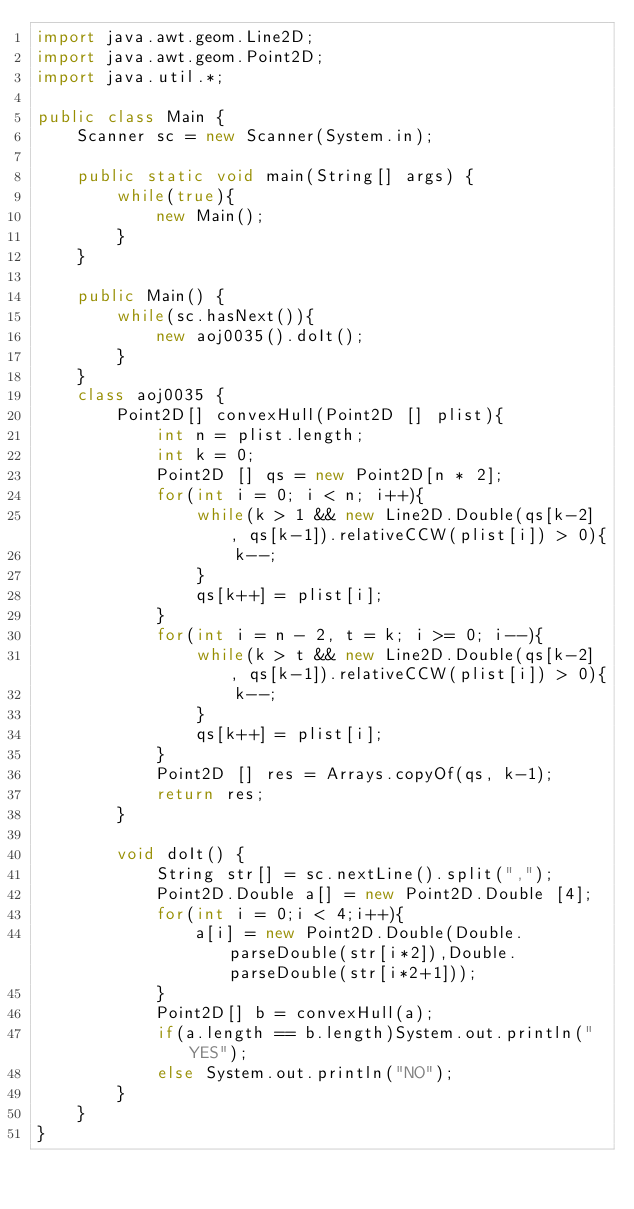<code> <loc_0><loc_0><loc_500><loc_500><_Java_>import java.awt.geom.Line2D;
import java.awt.geom.Point2D;
import java.util.*;

public class Main {
	Scanner sc = new Scanner(System.in);

	public static void main(String[] args) {
		while(true){
			new Main();	
		}
	}

	public Main() {
		while(sc.hasNext()){
			new aoj0035().doIt();
		}
	}
	class aoj0035 {
		Point2D[] convexHull(Point2D [] plist){
			int n = plist.length;
			int k = 0;
			Point2D [] qs = new Point2D[n * 2];
			for(int i = 0; i < n; i++){
				while(k > 1 && new Line2D.Double(qs[k-2] , qs[k-1]).relativeCCW(plist[i]) > 0){
					k--;
				}
				qs[k++] = plist[i];
			}
			for(int i = n - 2, t = k; i >= 0; i--){
				while(k > t && new Line2D.Double(qs[k-2] , qs[k-1]).relativeCCW(plist[i]) > 0){
					k--;
				}
				qs[k++] = plist[i];
			}
			Point2D [] res = Arrays.copyOf(qs, k-1);
			return res;
		}
		
		void doIt() {
			String str[] = sc.nextLine().split(",");
			Point2D.Double a[] = new Point2D.Double [4];
			for(int i = 0;i < 4;i++){
				a[i] = new Point2D.Double(Double.parseDouble(str[i*2]),Double.parseDouble(str[i*2+1]));
			}
			Point2D[] b = convexHull(a);
			if(a.length == b.length)System.out.println("YES");
			else System.out.println("NO");
		}
	}
}</code> 